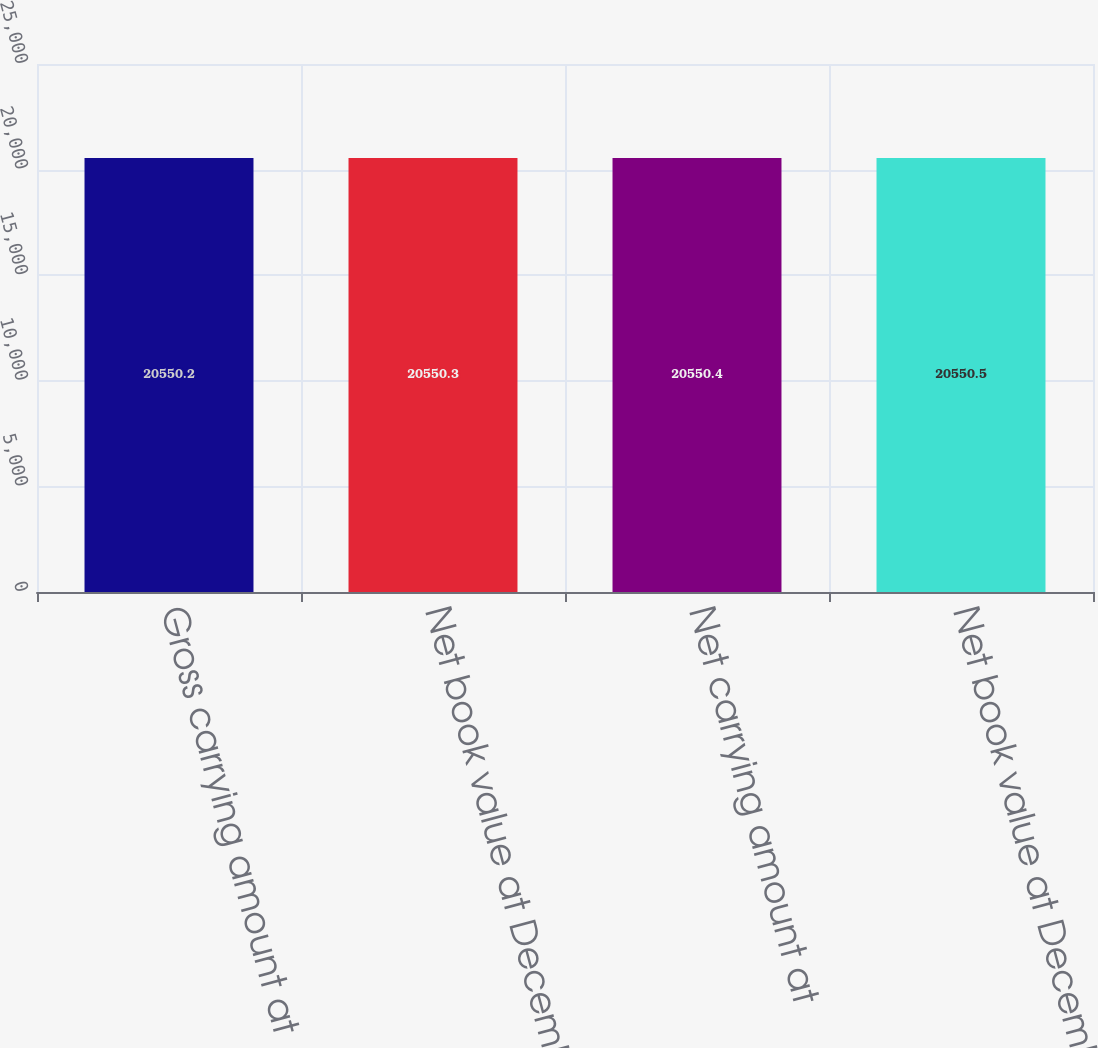Convert chart. <chart><loc_0><loc_0><loc_500><loc_500><bar_chart><fcel>Gross carrying amount at<fcel>Net book value at December 31<fcel>Net carrying amount at<fcel>Net book value at December 28<nl><fcel>20550.2<fcel>20550.3<fcel>20550.4<fcel>20550.5<nl></chart> 